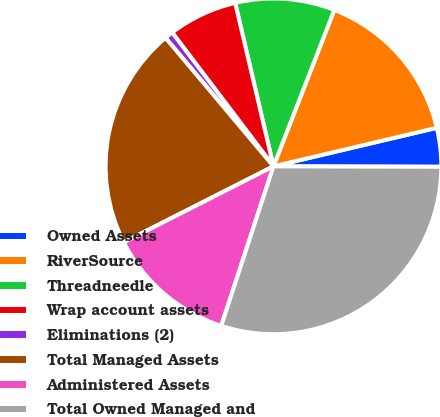<chart> <loc_0><loc_0><loc_500><loc_500><pie_chart><fcel>Owned Assets<fcel>RiverSource<fcel>Threadneedle<fcel>Wrap account assets<fcel>Eliminations (2)<fcel>Total Managed Assets<fcel>Administered Assets<fcel>Total Owned Managed and<nl><fcel>3.73%<fcel>15.41%<fcel>9.57%<fcel>6.65%<fcel>0.81%<fcel>21.36%<fcel>12.49%<fcel>30.0%<nl></chart> 